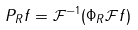<formula> <loc_0><loc_0><loc_500><loc_500>P _ { R } f = \mathcal { F } ^ { - 1 } ( \Phi _ { R } \mathcal { F } f )</formula> 